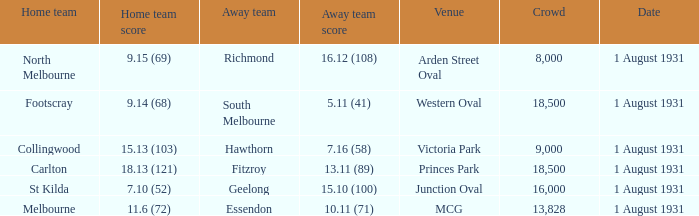What is the home team at the venue mcg? Melbourne. Can you parse all the data within this table? {'header': ['Home team', 'Home team score', 'Away team', 'Away team score', 'Venue', 'Crowd', 'Date'], 'rows': [['North Melbourne', '9.15 (69)', 'Richmond', '16.12 (108)', 'Arden Street Oval', '8,000', '1 August 1931'], ['Footscray', '9.14 (68)', 'South Melbourne', '5.11 (41)', 'Western Oval', '18,500', '1 August 1931'], ['Collingwood', '15.13 (103)', 'Hawthorn', '7.16 (58)', 'Victoria Park', '9,000', '1 August 1931'], ['Carlton', '18.13 (121)', 'Fitzroy', '13.11 (89)', 'Princes Park', '18,500', '1 August 1931'], ['St Kilda', '7.10 (52)', 'Geelong', '15.10 (100)', 'Junction Oval', '16,000', '1 August 1931'], ['Melbourne', '11.6 (72)', 'Essendon', '10.11 (71)', 'MCG', '13,828', '1 August 1931']]} 